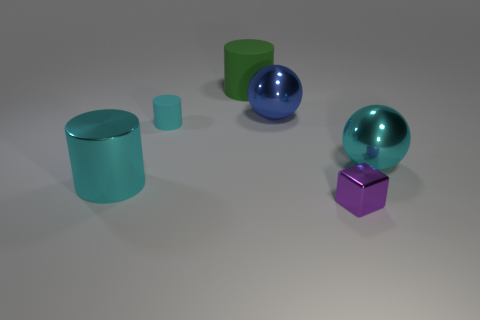Is the color of the ball on the left side of the cyan metal sphere the same as the small thing right of the big green matte object?
Make the answer very short. No. Are there any big metallic things of the same shape as the small cyan matte thing?
Provide a succinct answer. Yes. The blue shiny object that is the same size as the green matte cylinder is what shape?
Keep it short and to the point. Sphere. What number of objects have the same color as the tiny matte cylinder?
Provide a succinct answer. 2. There is a rubber cylinder to the left of the large green cylinder; what size is it?
Make the answer very short. Small. What number of things are the same size as the cyan shiny sphere?
Provide a short and direct response. 3. There is a cylinder that is the same material as the small block; what color is it?
Your response must be concise. Cyan. Is the number of cyan metallic cylinders that are to the left of the cyan metal ball less than the number of green things?
Offer a very short reply. No. What is the shape of the small cyan object that is made of the same material as the big green object?
Your response must be concise. Cylinder. What number of metallic objects are either small purple things or big cyan things?
Give a very brief answer. 3. 